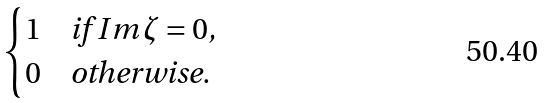Convert formula to latex. <formula><loc_0><loc_0><loc_500><loc_500>\begin{cases} 1 & \text {if $Im\,\zeta = 0$,} \\ 0 & \text {otherwise.} \end{cases}</formula> 